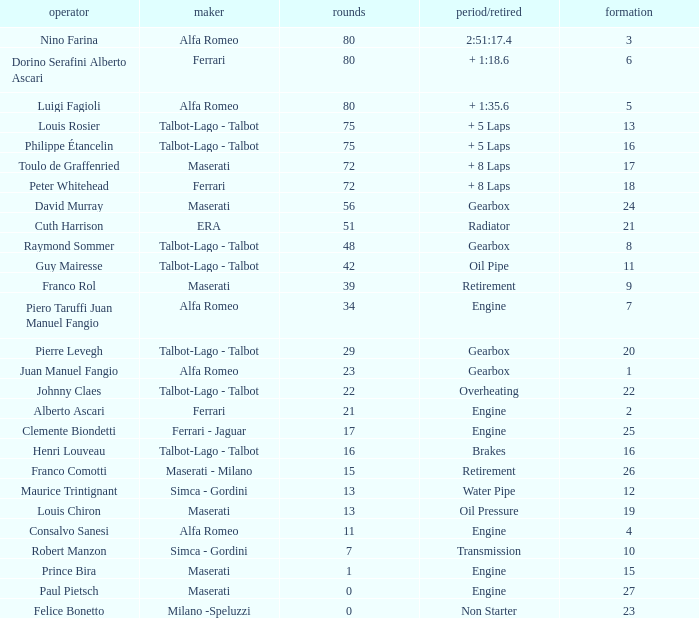When grid is less than 7, laps are greater than 17, and time/retired is + 1:35.6, who is the constructor? Alfa Romeo. 